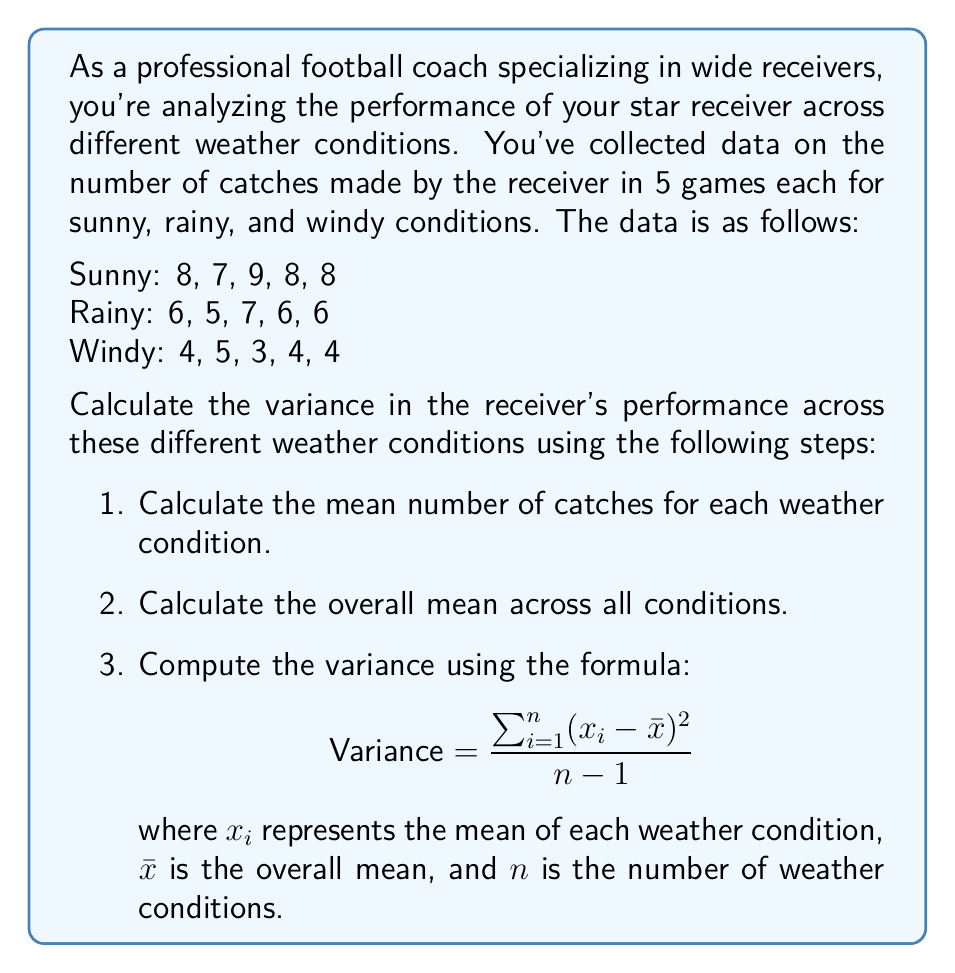Could you help me with this problem? Let's solve this problem step by step:

1. Calculate the mean number of catches for each weather condition:
   Sunny: $\frac{8 + 7 + 9 + 8 + 8}{5} = 8$
   Rainy: $\frac{6 + 5 + 7 + 6 + 6}{5} = 6$
   Windy: $\frac{4 + 5 + 3 + 4 + 4}{5} = 4$

2. Calculate the overall mean across all conditions:
   $\bar{x} = \frac{8 + 6 + 4}{3} = 6$

3. Compute the variance:
   Using the formula $\text{Variance} = \frac{\sum_{i=1}^{n} (x_i - \bar{x})^2}{n-1}$

   $(8 - 6)^2 + (6 - 6)^2 + (4 - 6)^2 = 4 + 0 + 4 = 8$

   $\text{Variance} = \frac{8}{3-1} = \frac{8}{2} = 4$

Therefore, the variance in the receiver's performance across different weather conditions is 4.
Answer: 4 